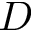<formula> <loc_0><loc_0><loc_500><loc_500>D</formula> 